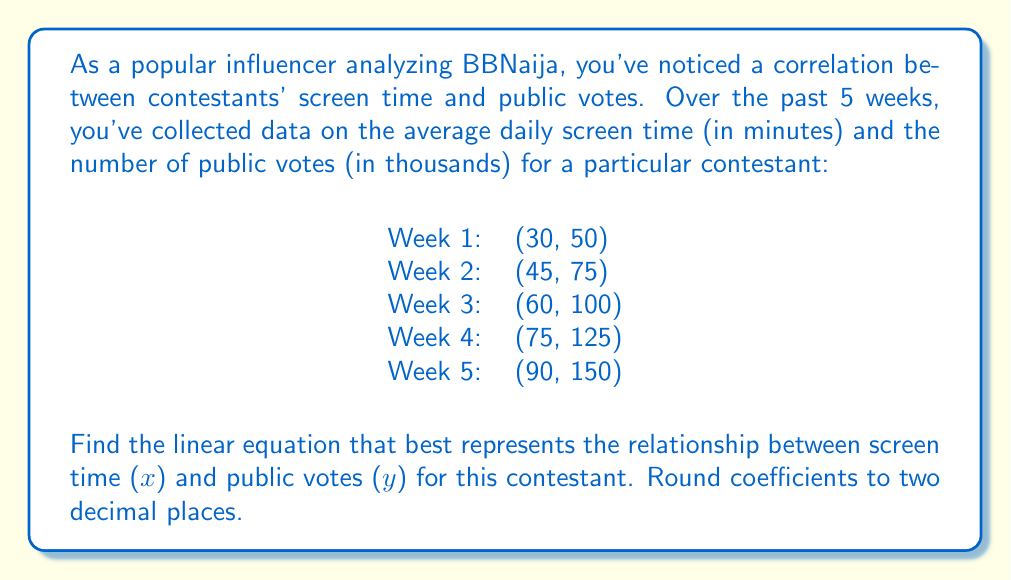Could you help me with this problem? To find the linear equation, we'll use the slope-intercept form: $y = mx + b$, where $m$ is the slope and $b$ is the y-intercept.

1. Calculate the slope using the point-slope formula:
   $m = \frac{y_2 - y_1}{x_2 - x_1}$
   Using the first and last data points:
   $m = \frac{150 - 50}{90 - 30} = \frac{100}{60} = 1.67$

2. Use the point-slope form to create an equation:
   $y - y_1 = m(x - x_1)$
   Using the first data point (30, 50):
   $y - 50 = 1.67(x - 30)$

3. Simplify the equation:
   $y - 50 = 1.67x - 50.1$
   $y = 1.67x - 50.1 + 50$
   $y = 1.67x - 0.1$

4. Round coefficients to two decimal places:
   $y = 1.67x - 0.10$

To verify, we can calculate the y-intercept using the slope and a known point:
$b = y - mx$
Using (30, 50): $b = 50 - 1.67(30) = 50 - 50.1 = -0.1$

This confirms our y-intercept of -0.10 after rounding.
Answer: $y = 1.67x - 0.10$ 